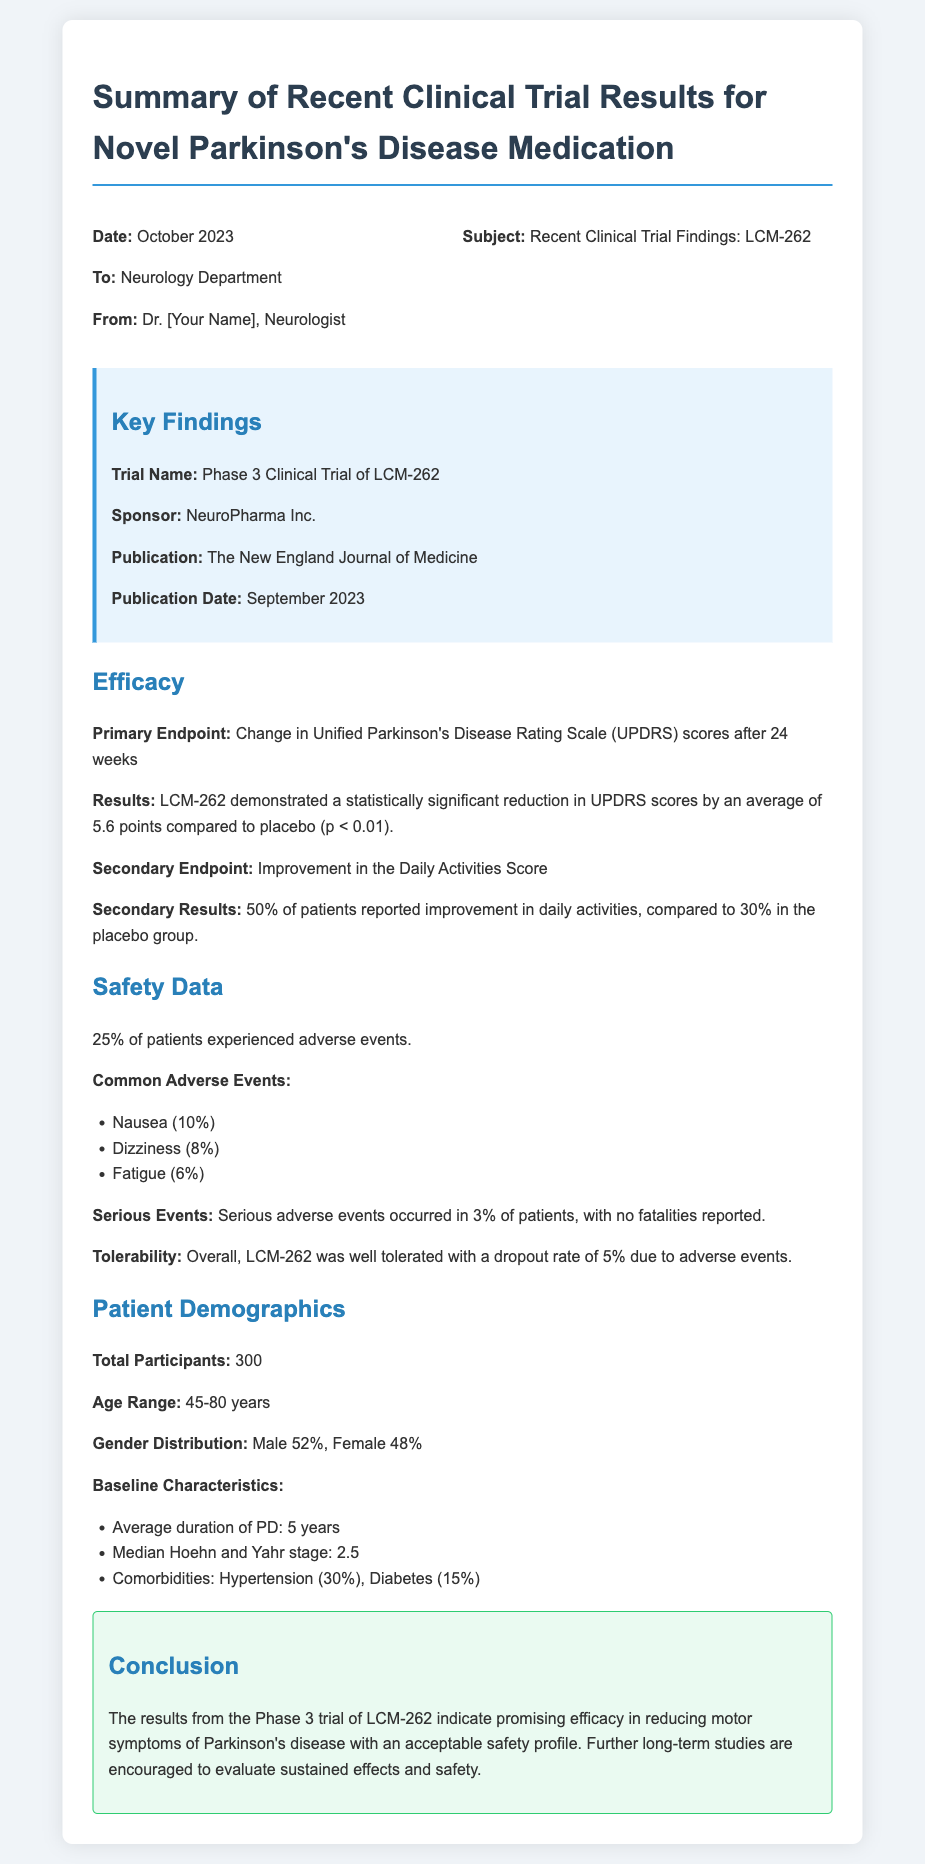What is the trial name? The trial name is found in the Key Findings section, which identifies the specific study being reported.
Answer: Phase 3 Clinical Trial of LCM-262 What was the primary endpoint of the trial? The primary endpoint is listed under the Efficacy section, detailing the main outcome measure for the study.
Answer: Change in Unified Parkinson's Disease Rating Scale (UPDRS) scores after 24 weeks What percentage of patients reported improvement in daily activities? This information is found in the Secondary Results subsection of the Efficacy section, indicating the outcomes of the trial.
Answer: 50% What was the dropout rate due to adverse events? The dropout rate is mentioned in the Safety Data section, which discusses tolerability and patient retention during the trial.
Answer: 5% How many total participants were in the trial? The total number of participants is indicated in the Patient Demographics section, summarizing the study's sample size.
Answer: 300 What was the median Hoehn and Yahr stage at baseline? This information appears under the Baseline Characteristics subsection of the Patient Demographics section, showing participant status at the beginning of the trial.
Answer: 2.5 What common adverse event affected the highest percentage of patients? The most common adverse event is listed in the Safety Data section, showing the frequency of each reported side effect.
Answer: Nausea What sponsor funded the trial? The sponsor information is provided in the Key Findings section, identifying who financed the study.
Answer: NeuroPharma Inc What were the median age range of the participants? The age range can be found in the Patient Demographics section, which provides insight into the participants involved in the trial.
Answer: 45-80 years 